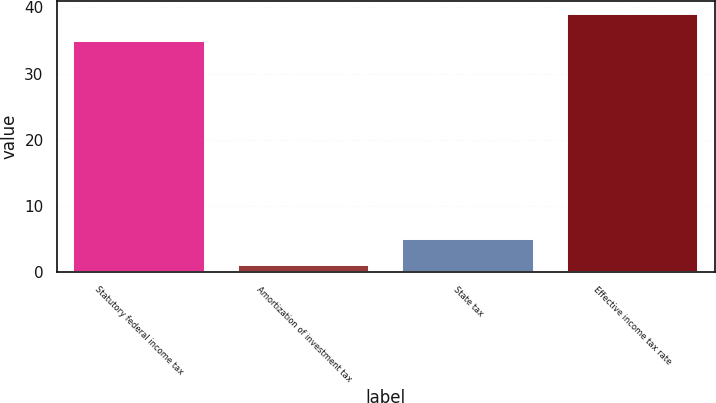Convert chart. <chart><loc_0><loc_0><loc_500><loc_500><bar_chart><fcel>Statutory federal income tax<fcel>Amortization of investment tax<fcel>State tax<fcel>Effective income tax rate<nl><fcel>35<fcel>1<fcel>5<fcel>39<nl></chart> 